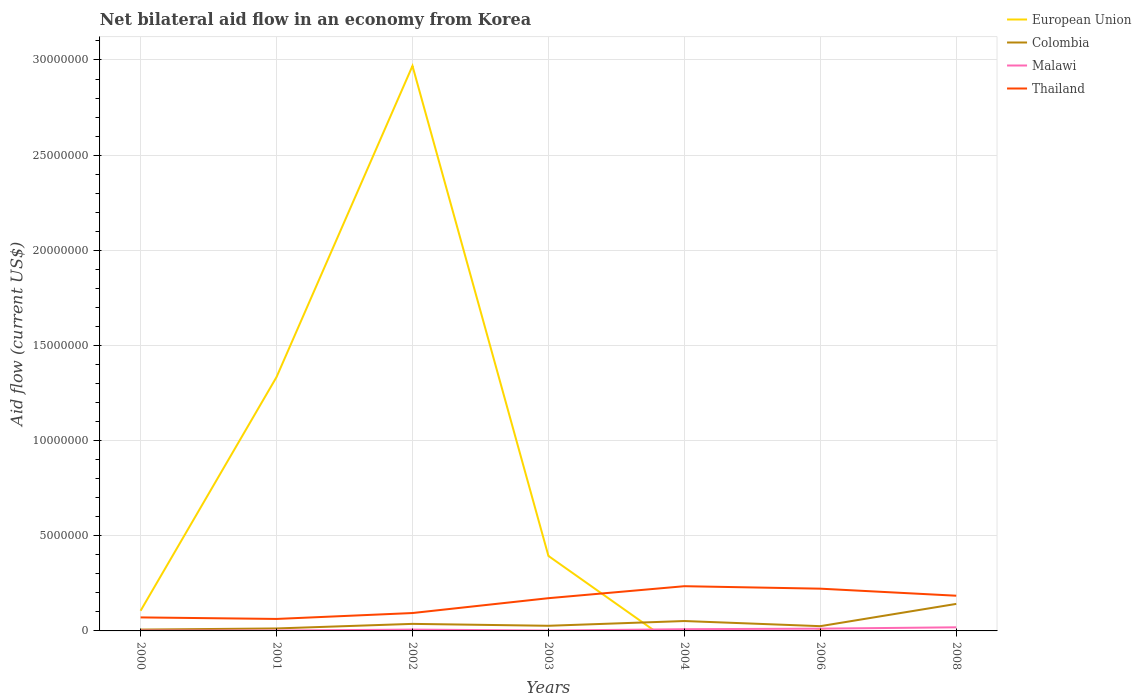Across all years, what is the maximum net bilateral aid flow in Malawi?
Provide a short and direct response. 2.00e+04. What is the total net bilateral aid flow in Thailand in the graph?
Make the answer very short. -7.80e+05. What is the difference between the highest and the lowest net bilateral aid flow in Malawi?
Provide a short and direct response. 3. How many years are there in the graph?
Offer a very short reply. 7. What is the difference between two consecutive major ticks on the Y-axis?
Your answer should be compact. 5.00e+06. Are the values on the major ticks of Y-axis written in scientific E-notation?
Offer a very short reply. No. Does the graph contain grids?
Make the answer very short. Yes. How are the legend labels stacked?
Provide a succinct answer. Vertical. What is the title of the graph?
Provide a succinct answer. Net bilateral aid flow in an economy from Korea. Does "Netherlands" appear as one of the legend labels in the graph?
Provide a succinct answer. No. What is the label or title of the X-axis?
Keep it short and to the point. Years. What is the label or title of the Y-axis?
Your response must be concise. Aid flow (current US$). What is the Aid flow (current US$) of European Union in 2000?
Give a very brief answer. 1.06e+06. What is the Aid flow (current US$) of Thailand in 2000?
Your answer should be very brief. 7.10e+05. What is the Aid flow (current US$) in European Union in 2001?
Your answer should be very brief. 1.33e+07. What is the Aid flow (current US$) of Malawi in 2001?
Your answer should be compact. 2.00e+04. What is the Aid flow (current US$) in Thailand in 2001?
Your response must be concise. 6.30e+05. What is the Aid flow (current US$) in European Union in 2002?
Keep it short and to the point. 2.97e+07. What is the Aid flow (current US$) of Thailand in 2002?
Offer a terse response. 9.40e+05. What is the Aid flow (current US$) of European Union in 2003?
Keep it short and to the point. 3.94e+06. What is the Aid flow (current US$) in Malawi in 2003?
Make the answer very short. 2.00e+04. What is the Aid flow (current US$) of Thailand in 2003?
Make the answer very short. 1.72e+06. What is the Aid flow (current US$) of Colombia in 2004?
Provide a short and direct response. 5.20e+05. What is the Aid flow (current US$) in Thailand in 2004?
Ensure brevity in your answer.  2.35e+06. What is the Aid flow (current US$) of European Union in 2006?
Ensure brevity in your answer.  5.00e+04. What is the Aid flow (current US$) in Colombia in 2006?
Keep it short and to the point. 2.50e+05. What is the Aid flow (current US$) of Thailand in 2006?
Provide a succinct answer. 2.22e+06. What is the Aid flow (current US$) in European Union in 2008?
Provide a succinct answer. 0. What is the Aid flow (current US$) in Colombia in 2008?
Keep it short and to the point. 1.42e+06. What is the Aid flow (current US$) of Thailand in 2008?
Provide a succinct answer. 1.85e+06. Across all years, what is the maximum Aid flow (current US$) of European Union?
Provide a short and direct response. 2.97e+07. Across all years, what is the maximum Aid flow (current US$) in Colombia?
Offer a terse response. 1.42e+06. Across all years, what is the maximum Aid flow (current US$) in Thailand?
Offer a very short reply. 2.35e+06. Across all years, what is the minimum Aid flow (current US$) of European Union?
Keep it short and to the point. 0. Across all years, what is the minimum Aid flow (current US$) of Colombia?
Provide a succinct answer. 7.00e+04. Across all years, what is the minimum Aid flow (current US$) of Malawi?
Your answer should be compact. 2.00e+04. Across all years, what is the minimum Aid flow (current US$) of Thailand?
Your answer should be compact. 6.30e+05. What is the total Aid flow (current US$) of European Union in the graph?
Give a very brief answer. 4.81e+07. What is the total Aid flow (current US$) of Colombia in the graph?
Your answer should be compact. 3.03e+06. What is the total Aid flow (current US$) in Malawi in the graph?
Offer a terse response. 5.30e+05. What is the total Aid flow (current US$) of Thailand in the graph?
Give a very brief answer. 1.04e+07. What is the difference between the Aid flow (current US$) of European Union in 2000 and that in 2001?
Provide a succinct answer. -1.23e+07. What is the difference between the Aid flow (current US$) in Colombia in 2000 and that in 2001?
Your response must be concise. -6.00e+04. What is the difference between the Aid flow (current US$) in Thailand in 2000 and that in 2001?
Your answer should be very brief. 8.00e+04. What is the difference between the Aid flow (current US$) of European Union in 2000 and that in 2002?
Give a very brief answer. -2.86e+07. What is the difference between the Aid flow (current US$) in Colombia in 2000 and that in 2002?
Your response must be concise. -3.00e+05. What is the difference between the Aid flow (current US$) of Thailand in 2000 and that in 2002?
Your response must be concise. -2.30e+05. What is the difference between the Aid flow (current US$) of European Union in 2000 and that in 2003?
Offer a very short reply. -2.88e+06. What is the difference between the Aid flow (current US$) of Malawi in 2000 and that in 2003?
Keep it short and to the point. 0. What is the difference between the Aid flow (current US$) of Thailand in 2000 and that in 2003?
Make the answer very short. -1.01e+06. What is the difference between the Aid flow (current US$) in Colombia in 2000 and that in 2004?
Your response must be concise. -4.50e+05. What is the difference between the Aid flow (current US$) of Thailand in 2000 and that in 2004?
Provide a succinct answer. -1.64e+06. What is the difference between the Aid flow (current US$) in European Union in 2000 and that in 2006?
Make the answer very short. 1.01e+06. What is the difference between the Aid flow (current US$) of Thailand in 2000 and that in 2006?
Make the answer very short. -1.51e+06. What is the difference between the Aid flow (current US$) in Colombia in 2000 and that in 2008?
Make the answer very short. -1.35e+06. What is the difference between the Aid flow (current US$) in Malawi in 2000 and that in 2008?
Ensure brevity in your answer.  -1.70e+05. What is the difference between the Aid flow (current US$) in Thailand in 2000 and that in 2008?
Your response must be concise. -1.14e+06. What is the difference between the Aid flow (current US$) of European Union in 2001 and that in 2002?
Your answer should be compact. -1.64e+07. What is the difference between the Aid flow (current US$) in Malawi in 2001 and that in 2002?
Provide a succinct answer. -5.00e+04. What is the difference between the Aid flow (current US$) of Thailand in 2001 and that in 2002?
Your answer should be compact. -3.10e+05. What is the difference between the Aid flow (current US$) in European Union in 2001 and that in 2003?
Make the answer very short. 9.40e+06. What is the difference between the Aid flow (current US$) in Thailand in 2001 and that in 2003?
Offer a very short reply. -1.09e+06. What is the difference between the Aid flow (current US$) in Colombia in 2001 and that in 2004?
Your answer should be compact. -3.90e+05. What is the difference between the Aid flow (current US$) of Thailand in 2001 and that in 2004?
Provide a short and direct response. -1.72e+06. What is the difference between the Aid flow (current US$) in European Union in 2001 and that in 2006?
Offer a terse response. 1.33e+07. What is the difference between the Aid flow (current US$) in Malawi in 2001 and that in 2006?
Give a very brief answer. -1.00e+05. What is the difference between the Aid flow (current US$) in Thailand in 2001 and that in 2006?
Your answer should be compact. -1.59e+06. What is the difference between the Aid flow (current US$) of Colombia in 2001 and that in 2008?
Ensure brevity in your answer.  -1.29e+06. What is the difference between the Aid flow (current US$) of Thailand in 2001 and that in 2008?
Your response must be concise. -1.22e+06. What is the difference between the Aid flow (current US$) of European Union in 2002 and that in 2003?
Offer a terse response. 2.58e+07. What is the difference between the Aid flow (current US$) in Colombia in 2002 and that in 2003?
Provide a succinct answer. 1.00e+05. What is the difference between the Aid flow (current US$) in Malawi in 2002 and that in 2003?
Offer a terse response. 5.00e+04. What is the difference between the Aid flow (current US$) of Thailand in 2002 and that in 2003?
Make the answer very short. -7.80e+05. What is the difference between the Aid flow (current US$) of Thailand in 2002 and that in 2004?
Ensure brevity in your answer.  -1.41e+06. What is the difference between the Aid flow (current US$) in European Union in 2002 and that in 2006?
Offer a terse response. 2.96e+07. What is the difference between the Aid flow (current US$) of Colombia in 2002 and that in 2006?
Make the answer very short. 1.20e+05. What is the difference between the Aid flow (current US$) of Malawi in 2002 and that in 2006?
Your response must be concise. -5.00e+04. What is the difference between the Aid flow (current US$) in Thailand in 2002 and that in 2006?
Ensure brevity in your answer.  -1.28e+06. What is the difference between the Aid flow (current US$) in Colombia in 2002 and that in 2008?
Your answer should be very brief. -1.05e+06. What is the difference between the Aid flow (current US$) of Malawi in 2002 and that in 2008?
Ensure brevity in your answer.  -1.20e+05. What is the difference between the Aid flow (current US$) of Thailand in 2002 and that in 2008?
Offer a very short reply. -9.10e+05. What is the difference between the Aid flow (current US$) of Malawi in 2003 and that in 2004?
Provide a short and direct response. -7.00e+04. What is the difference between the Aid flow (current US$) of Thailand in 2003 and that in 2004?
Your response must be concise. -6.30e+05. What is the difference between the Aid flow (current US$) in European Union in 2003 and that in 2006?
Your response must be concise. 3.89e+06. What is the difference between the Aid flow (current US$) in Malawi in 2003 and that in 2006?
Your answer should be compact. -1.00e+05. What is the difference between the Aid flow (current US$) in Thailand in 2003 and that in 2006?
Provide a short and direct response. -5.00e+05. What is the difference between the Aid flow (current US$) in Colombia in 2003 and that in 2008?
Your answer should be compact. -1.15e+06. What is the difference between the Aid flow (current US$) in Malawi in 2003 and that in 2008?
Make the answer very short. -1.70e+05. What is the difference between the Aid flow (current US$) in Thailand in 2003 and that in 2008?
Give a very brief answer. -1.30e+05. What is the difference between the Aid flow (current US$) of Colombia in 2004 and that in 2006?
Your answer should be very brief. 2.70e+05. What is the difference between the Aid flow (current US$) of Malawi in 2004 and that in 2006?
Provide a succinct answer. -3.00e+04. What is the difference between the Aid flow (current US$) of Colombia in 2004 and that in 2008?
Your answer should be very brief. -9.00e+05. What is the difference between the Aid flow (current US$) in Colombia in 2006 and that in 2008?
Your answer should be compact. -1.17e+06. What is the difference between the Aid flow (current US$) in European Union in 2000 and the Aid flow (current US$) in Colombia in 2001?
Make the answer very short. 9.30e+05. What is the difference between the Aid flow (current US$) of European Union in 2000 and the Aid flow (current US$) of Malawi in 2001?
Your answer should be compact. 1.04e+06. What is the difference between the Aid flow (current US$) in Colombia in 2000 and the Aid flow (current US$) in Malawi in 2001?
Provide a short and direct response. 5.00e+04. What is the difference between the Aid flow (current US$) of Colombia in 2000 and the Aid flow (current US$) of Thailand in 2001?
Offer a terse response. -5.60e+05. What is the difference between the Aid flow (current US$) in Malawi in 2000 and the Aid flow (current US$) in Thailand in 2001?
Provide a short and direct response. -6.10e+05. What is the difference between the Aid flow (current US$) of European Union in 2000 and the Aid flow (current US$) of Colombia in 2002?
Your response must be concise. 6.90e+05. What is the difference between the Aid flow (current US$) in European Union in 2000 and the Aid flow (current US$) in Malawi in 2002?
Your response must be concise. 9.90e+05. What is the difference between the Aid flow (current US$) in Colombia in 2000 and the Aid flow (current US$) in Malawi in 2002?
Give a very brief answer. 0. What is the difference between the Aid flow (current US$) in Colombia in 2000 and the Aid flow (current US$) in Thailand in 2002?
Provide a short and direct response. -8.70e+05. What is the difference between the Aid flow (current US$) in Malawi in 2000 and the Aid flow (current US$) in Thailand in 2002?
Give a very brief answer. -9.20e+05. What is the difference between the Aid flow (current US$) of European Union in 2000 and the Aid flow (current US$) of Colombia in 2003?
Give a very brief answer. 7.90e+05. What is the difference between the Aid flow (current US$) in European Union in 2000 and the Aid flow (current US$) in Malawi in 2003?
Offer a very short reply. 1.04e+06. What is the difference between the Aid flow (current US$) of European Union in 2000 and the Aid flow (current US$) of Thailand in 2003?
Provide a succinct answer. -6.60e+05. What is the difference between the Aid flow (current US$) of Colombia in 2000 and the Aid flow (current US$) of Thailand in 2003?
Provide a short and direct response. -1.65e+06. What is the difference between the Aid flow (current US$) of Malawi in 2000 and the Aid flow (current US$) of Thailand in 2003?
Provide a succinct answer. -1.70e+06. What is the difference between the Aid flow (current US$) of European Union in 2000 and the Aid flow (current US$) of Colombia in 2004?
Provide a succinct answer. 5.40e+05. What is the difference between the Aid flow (current US$) of European Union in 2000 and the Aid flow (current US$) of Malawi in 2004?
Offer a terse response. 9.70e+05. What is the difference between the Aid flow (current US$) in European Union in 2000 and the Aid flow (current US$) in Thailand in 2004?
Offer a terse response. -1.29e+06. What is the difference between the Aid flow (current US$) of Colombia in 2000 and the Aid flow (current US$) of Thailand in 2004?
Your response must be concise. -2.28e+06. What is the difference between the Aid flow (current US$) in Malawi in 2000 and the Aid flow (current US$) in Thailand in 2004?
Keep it short and to the point. -2.33e+06. What is the difference between the Aid flow (current US$) in European Union in 2000 and the Aid flow (current US$) in Colombia in 2006?
Keep it short and to the point. 8.10e+05. What is the difference between the Aid flow (current US$) of European Union in 2000 and the Aid flow (current US$) of Malawi in 2006?
Your answer should be compact. 9.40e+05. What is the difference between the Aid flow (current US$) in European Union in 2000 and the Aid flow (current US$) in Thailand in 2006?
Offer a very short reply. -1.16e+06. What is the difference between the Aid flow (current US$) in Colombia in 2000 and the Aid flow (current US$) in Thailand in 2006?
Provide a short and direct response. -2.15e+06. What is the difference between the Aid flow (current US$) of Malawi in 2000 and the Aid flow (current US$) of Thailand in 2006?
Your answer should be compact. -2.20e+06. What is the difference between the Aid flow (current US$) of European Union in 2000 and the Aid flow (current US$) of Colombia in 2008?
Provide a succinct answer. -3.60e+05. What is the difference between the Aid flow (current US$) of European Union in 2000 and the Aid flow (current US$) of Malawi in 2008?
Your answer should be compact. 8.70e+05. What is the difference between the Aid flow (current US$) in European Union in 2000 and the Aid flow (current US$) in Thailand in 2008?
Provide a succinct answer. -7.90e+05. What is the difference between the Aid flow (current US$) of Colombia in 2000 and the Aid flow (current US$) of Malawi in 2008?
Give a very brief answer. -1.20e+05. What is the difference between the Aid flow (current US$) in Colombia in 2000 and the Aid flow (current US$) in Thailand in 2008?
Your answer should be compact. -1.78e+06. What is the difference between the Aid flow (current US$) in Malawi in 2000 and the Aid flow (current US$) in Thailand in 2008?
Provide a succinct answer. -1.83e+06. What is the difference between the Aid flow (current US$) of European Union in 2001 and the Aid flow (current US$) of Colombia in 2002?
Give a very brief answer. 1.30e+07. What is the difference between the Aid flow (current US$) of European Union in 2001 and the Aid flow (current US$) of Malawi in 2002?
Keep it short and to the point. 1.33e+07. What is the difference between the Aid flow (current US$) in European Union in 2001 and the Aid flow (current US$) in Thailand in 2002?
Ensure brevity in your answer.  1.24e+07. What is the difference between the Aid flow (current US$) in Colombia in 2001 and the Aid flow (current US$) in Malawi in 2002?
Make the answer very short. 6.00e+04. What is the difference between the Aid flow (current US$) of Colombia in 2001 and the Aid flow (current US$) of Thailand in 2002?
Make the answer very short. -8.10e+05. What is the difference between the Aid flow (current US$) of Malawi in 2001 and the Aid flow (current US$) of Thailand in 2002?
Your answer should be compact. -9.20e+05. What is the difference between the Aid flow (current US$) of European Union in 2001 and the Aid flow (current US$) of Colombia in 2003?
Keep it short and to the point. 1.31e+07. What is the difference between the Aid flow (current US$) in European Union in 2001 and the Aid flow (current US$) in Malawi in 2003?
Give a very brief answer. 1.33e+07. What is the difference between the Aid flow (current US$) in European Union in 2001 and the Aid flow (current US$) in Thailand in 2003?
Provide a succinct answer. 1.16e+07. What is the difference between the Aid flow (current US$) in Colombia in 2001 and the Aid flow (current US$) in Thailand in 2003?
Keep it short and to the point. -1.59e+06. What is the difference between the Aid flow (current US$) in Malawi in 2001 and the Aid flow (current US$) in Thailand in 2003?
Provide a short and direct response. -1.70e+06. What is the difference between the Aid flow (current US$) in European Union in 2001 and the Aid flow (current US$) in Colombia in 2004?
Your answer should be compact. 1.28e+07. What is the difference between the Aid flow (current US$) in European Union in 2001 and the Aid flow (current US$) in Malawi in 2004?
Your answer should be compact. 1.32e+07. What is the difference between the Aid flow (current US$) of European Union in 2001 and the Aid flow (current US$) of Thailand in 2004?
Your answer should be compact. 1.10e+07. What is the difference between the Aid flow (current US$) in Colombia in 2001 and the Aid flow (current US$) in Thailand in 2004?
Offer a terse response. -2.22e+06. What is the difference between the Aid flow (current US$) of Malawi in 2001 and the Aid flow (current US$) of Thailand in 2004?
Give a very brief answer. -2.33e+06. What is the difference between the Aid flow (current US$) in European Union in 2001 and the Aid flow (current US$) in Colombia in 2006?
Your response must be concise. 1.31e+07. What is the difference between the Aid flow (current US$) of European Union in 2001 and the Aid flow (current US$) of Malawi in 2006?
Give a very brief answer. 1.32e+07. What is the difference between the Aid flow (current US$) in European Union in 2001 and the Aid flow (current US$) in Thailand in 2006?
Provide a short and direct response. 1.11e+07. What is the difference between the Aid flow (current US$) in Colombia in 2001 and the Aid flow (current US$) in Malawi in 2006?
Ensure brevity in your answer.  10000. What is the difference between the Aid flow (current US$) of Colombia in 2001 and the Aid flow (current US$) of Thailand in 2006?
Provide a short and direct response. -2.09e+06. What is the difference between the Aid flow (current US$) of Malawi in 2001 and the Aid flow (current US$) of Thailand in 2006?
Your response must be concise. -2.20e+06. What is the difference between the Aid flow (current US$) in European Union in 2001 and the Aid flow (current US$) in Colombia in 2008?
Offer a terse response. 1.19e+07. What is the difference between the Aid flow (current US$) of European Union in 2001 and the Aid flow (current US$) of Malawi in 2008?
Keep it short and to the point. 1.32e+07. What is the difference between the Aid flow (current US$) of European Union in 2001 and the Aid flow (current US$) of Thailand in 2008?
Provide a short and direct response. 1.15e+07. What is the difference between the Aid flow (current US$) in Colombia in 2001 and the Aid flow (current US$) in Malawi in 2008?
Your answer should be very brief. -6.00e+04. What is the difference between the Aid flow (current US$) in Colombia in 2001 and the Aid flow (current US$) in Thailand in 2008?
Keep it short and to the point. -1.72e+06. What is the difference between the Aid flow (current US$) in Malawi in 2001 and the Aid flow (current US$) in Thailand in 2008?
Offer a very short reply. -1.83e+06. What is the difference between the Aid flow (current US$) in European Union in 2002 and the Aid flow (current US$) in Colombia in 2003?
Offer a terse response. 2.94e+07. What is the difference between the Aid flow (current US$) of European Union in 2002 and the Aid flow (current US$) of Malawi in 2003?
Give a very brief answer. 2.97e+07. What is the difference between the Aid flow (current US$) of European Union in 2002 and the Aid flow (current US$) of Thailand in 2003?
Ensure brevity in your answer.  2.80e+07. What is the difference between the Aid flow (current US$) in Colombia in 2002 and the Aid flow (current US$) in Malawi in 2003?
Your response must be concise. 3.50e+05. What is the difference between the Aid flow (current US$) in Colombia in 2002 and the Aid flow (current US$) in Thailand in 2003?
Your answer should be very brief. -1.35e+06. What is the difference between the Aid flow (current US$) of Malawi in 2002 and the Aid flow (current US$) of Thailand in 2003?
Your answer should be very brief. -1.65e+06. What is the difference between the Aid flow (current US$) of European Union in 2002 and the Aid flow (current US$) of Colombia in 2004?
Make the answer very short. 2.92e+07. What is the difference between the Aid flow (current US$) in European Union in 2002 and the Aid flow (current US$) in Malawi in 2004?
Give a very brief answer. 2.96e+07. What is the difference between the Aid flow (current US$) of European Union in 2002 and the Aid flow (current US$) of Thailand in 2004?
Your answer should be very brief. 2.73e+07. What is the difference between the Aid flow (current US$) in Colombia in 2002 and the Aid flow (current US$) in Malawi in 2004?
Offer a very short reply. 2.80e+05. What is the difference between the Aid flow (current US$) in Colombia in 2002 and the Aid flow (current US$) in Thailand in 2004?
Provide a succinct answer. -1.98e+06. What is the difference between the Aid flow (current US$) in Malawi in 2002 and the Aid flow (current US$) in Thailand in 2004?
Your response must be concise. -2.28e+06. What is the difference between the Aid flow (current US$) in European Union in 2002 and the Aid flow (current US$) in Colombia in 2006?
Provide a short and direct response. 2.94e+07. What is the difference between the Aid flow (current US$) of European Union in 2002 and the Aid flow (current US$) of Malawi in 2006?
Your answer should be compact. 2.96e+07. What is the difference between the Aid flow (current US$) of European Union in 2002 and the Aid flow (current US$) of Thailand in 2006?
Offer a very short reply. 2.75e+07. What is the difference between the Aid flow (current US$) of Colombia in 2002 and the Aid flow (current US$) of Malawi in 2006?
Offer a terse response. 2.50e+05. What is the difference between the Aid flow (current US$) of Colombia in 2002 and the Aid flow (current US$) of Thailand in 2006?
Provide a succinct answer. -1.85e+06. What is the difference between the Aid flow (current US$) in Malawi in 2002 and the Aid flow (current US$) in Thailand in 2006?
Your answer should be very brief. -2.15e+06. What is the difference between the Aid flow (current US$) in European Union in 2002 and the Aid flow (current US$) in Colombia in 2008?
Make the answer very short. 2.83e+07. What is the difference between the Aid flow (current US$) in European Union in 2002 and the Aid flow (current US$) in Malawi in 2008?
Your answer should be very brief. 2.95e+07. What is the difference between the Aid flow (current US$) in European Union in 2002 and the Aid flow (current US$) in Thailand in 2008?
Give a very brief answer. 2.78e+07. What is the difference between the Aid flow (current US$) of Colombia in 2002 and the Aid flow (current US$) of Malawi in 2008?
Give a very brief answer. 1.80e+05. What is the difference between the Aid flow (current US$) in Colombia in 2002 and the Aid flow (current US$) in Thailand in 2008?
Provide a succinct answer. -1.48e+06. What is the difference between the Aid flow (current US$) in Malawi in 2002 and the Aid flow (current US$) in Thailand in 2008?
Offer a very short reply. -1.78e+06. What is the difference between the Aid flow (current US$) of European Union in 2003 and the Aid flow (current US$) of Colombia in 2004?
Offer a very short reply. 3.42e+06. What is the difference between the Aid flow (current US$) in European Union in 2003 and the Aid flow (current US$) in Malawi in 2004?
Your answer should be very brief. 3.85e+06. What is the difference between the Aid flow (current US$) of European Union in 2003 and the Aid flow (current US$) of Thailand in 2004?
Make the answer very short. 1.59e+06. What is the difference between the Aid flow (current US$) in Colombia in 2003 and the Aid flow (current US$) in Thailand in 2004?
Give a very brief answer. -2.08e+06. What is the difference between the Aid flow (current US$) in Malawi in 2003 and the Aid flow (current US$) in Thailand in 2004?
Ensure brevity in your answer.  -2.33e+06. What is the difference between the Aid flow (current US$) in European Union in 2003 and the Aid flow (current US$) in Colombia in 2006?
Make the answer very short. 3.69e+06. What is the difference between the Aid flow (current US$) of European Union in 2003 and the Aid flow (current US$) of Malawi in 2006?
Offer a very short reply. 3.82e+06. What is the difference between the Aid flow (current US$) of European Union in 2003 and the Aid flow (current US$) of Thailand in 2006?
Your answer should be compact. 1.72e+06. What is the difference between the Aid flow (current US$) in Colombia in 2003 and the Aid flow (current US$) in Malawi in 2006?
Provide a short and direct response. 1.50e+05. What is the difference between the Aid flow (current US$) of Colombia in 2003 and the Aid flow (current US$) of Thailand in 2006?
Make the answer very short. -1.95e+06. What is the difference between the Aid flow (current US$) in Malawi in 2003 and the Aid flow (current US$) in Thailand in 2006?
Your response must be concise. -2.20e+06. What is the difference between the Aid flow (current US$) of European Union in 2003 and the Aid flow (current US$) of Colombia in 2008?
Your response must be concise. 2.52e+06. What is the difference between the Aid flow (current US$) of European Union in 2003 and the Aid flow (current US$) of Malawi in 2008?
Provide a short and direct response. 3.75e+06. What is the difference between the Aid flow (current US$) in European Union in 2003 and the Aid flow (current US$) in Thailand in 2008?
Make the answer very short. 2.09e+06. What is the difference between the Aid flow (current US$) in Colombia in 2003 and the Aid flow (current US$) in Thailand in 2008?
Your answer should be compact. -1.58e+06. What is the difference between the Aid flow (current US$) of Malawi in 2003 and the Aid flow (current US$) of Thailand in 2008?
Your answer should be compact. -1.83e+06. What is the difference between the Aid flow (current US$) in Colombia in 2004 and the Aid flow (current US$) in Thailand in 2006?
Ensure brevity in your answer.  -1.70e+06. What is the difference between the Aid flow (current US$) in Malawi in 2004 and the Aid flow (current US$) in Thailand in 2006?
Give a very brief answer. -2.13e+06. What is the difference between the Aid flow (current US$) in Colombia in 2004 and the Aid flow (current US$) in Thailand in 2008?
Provide a succinct answer. -1.33e+06. What is the difference between the Aid flow (current US$) in Malawi in 2004 and the Aid flow (current US$) in Thailand in 2008?
Your answer should be very brief. -1.76e+06. What is the difference between the Aid flow (current US$) in European Union in 2006 and the Aid flow (current US$) in Colombia in 2008?
Your answer should be compact. -1.37e+06. What is the difference between the Aid flow (current US$) of European Union in 2006 and the Aid flow (current US$) of Thailand in 2008?
Keep it short and to the point. -1.80e+06. What is the difference between the Aid flow (current US$) of Colombia in 2006 and the Aid flow (current US$) of Malawi in 2008?
Offer a terse response. 6.00e+04. What is the difference between the Aid flow (current US$) in Colombia in 2006 and the Aid flow (current US$) in Thailand in 2008?
Ensure brevity in your answer.  -1.60e+06. What is the difference between the Aid flow (current US$) of Malawi in 2006 and the Aid flow (current US$) of Thailand in 2008?
Your answer should be compact. -1.73e+06. What is the average Aid flow (current US$) in European Union per year?
Your answer should be compact. 6.87e+06. What is the average Aid flow (current US$) of Colombia per year?
Your answer should be compact. 4.33e+05. What is the average Aid flow (current US$) of Malawi per year?
Your answer should be compact. 7.57e+04. What is the average Aid flow (current US$) in Thailand per year?
Offer a very short reply. 1.49e+06. In the year 2000, what is the difference between the Aid flow (current US$) in European Union and Aid flow (current US$) in Colombia?
Provide a succinct answer. 9.90e+05. In the year 2000, what is the difference between the Aid flow (current US$) in European Union and Aid flow (current US$) in Malawi?
Your response must be concise. 1.04e+06. In the year 2000, what is the difference between the Aid flow (current US$) in European Union and Aid flow (current US$) in Thailand?
Ensure brevity in your answer.  3.50e+05. In the year 2000, what is the difference between the Aid flow (current US$) of Colombia and Aid flow (current US$) of Malawi?
Your answer should be very brief. 5.00e+04. In the year 2000, what is the difference between the Aid flow (current US$) of Colombia and Aid flow (current US$) of Thailand?
Your answer should be very brief. -6.40e+05. In the year 2000, what is the difference between the Aid flow (current US$) in Malawi and Aid flow (current US$) in Thailand?
Ensure brevity in your answer.  -6.90e+05. In the year 2001, what is the difference between the Aid flow (current US$) in European Union and Aid flow (current US$) in Colombia?
Your response must be concise. 1.32e+07. In the year 2001, what is the difference between the Aid flow (current US$) in European Union and Aid flow (current US$) in Malawi?
Your answer should be very brief. 1.33e+07. In the year 2001, what is the difference between the Aid flow (current US$) in European Union and Aid flow (current US$) in Thailand?
Offer a terse response. 1.27e+07. In the year 2001, what is the difference between the Aid flow (current US$) in Colombia and Aid flow (current US$) in Malawi?
Your answer should be very brief. 1.10e+05. In the year 2001, what is the difference between the Aid flow (current US$) of Colombia and Aid flow (current US$) of Thailand?
Your response must be concise. -5.00e+05. In the year 2001, what is the difference between the Aid flow (current US$) in Malawi and Aid flow (current US$) in Thailand?
Make the answer very short. -6.10e+05. In the year 2002, what is the difference between the Aid flow (current US$) of European Union and Aid flow (current US$) of Colombia?
Keep it short and to the point. 2.93e+07. In the year 2002, what is the difference between the Aid flow (current US$) of European Union and Aid flow (current US$) of Malawi?
Ensure brevity in your answer.  2.96e+07. In the year 2002, what is the difference between the Aid flow (current US$) in European Union and Aid flow (current US$) in Thailand?
Your answer should be compact. 2.88e+07. In the year 2002, what is the difference between the Aid flow (current US$) in Colombia and Aid flow (current US$) in Malawi?
Your answer should be compact. 3.00e+05. In the year 2002, what is the difference between the Aid flow (current US$) in Colombia and Aid flow (current US$) in Thailand?
Offer a terse response. -5.70e+05. In the year 2002, what is the difference between the Aid flow (current US$) of Malawi and Aid flow (current US$) of Thailand?
Provide a short and direct response. -8.70e+05. In the year 2003, what is the difference between the Aid flow (current US$) in European Union and Aid flow (current US$) in Colombia?
Your answer should be very brief. 3.67e+06. In the year 2003, what is the difference between the Aid flow (current US$) in European Union and Aid flow (current US$) in Malawi?
Provide a short and direct response. 3.92e+06. In the year 2003, what is the difference between the Aid flow (current US$) in European Union and Aid flow (current US$) in Thailand?
Keep it short and to the point. 2.22e+06. In the year 2003, what is the difference between the Aid flow (current US$) of Colombia and Aid flow (current US$) of Malawi?
Offer a terse response. 2.50e+05. In the year 2003, what is the difference between the Aid flow (current US$) of Colombia and Aid flow (current US$) of Thailand?
Your answer should be very brief. -1.45e+06. In the year 2003, what is the difference between the Aid flow (current US$) of Malawi and Aid flow (current US$) of Thailand?
Offer a terse response. -1.70e+06. In the year 2004, what is the difference between the Aid flow (current US$) of Colombia and Aid flow (current US$) of Thailand?
Your answer should be very brief. -1.83e+06. In the year 2004, what is the difference between the Aid flow (current US$) of Malawi and Aid flow (current US$) of Thailand?
Provide a succinct answer. -2.26e+06. In the year 2006, what is the difference between the Aid flow (current US$) in European Union and Aid flow (current US$) in Thailand?
Your answer should be very brief. -2.17e+06. In the year 2006, what is the difference between the Aid flow (current US$) in Colombia and Aid flow (current US$) in Malawi?
Give a very brief answer. 1.30e+05. In the year 2006, what is the difference between the Aid flow (current US$) of Colombia and Aid flow (current US$) of Thailand?
Your answer should be compact. -1.97e+06. In the year 2006, what is the difference between the Aid flow (current US$) in Malawi and Aid flow (current US$) in Thailand?
Give a very brief answer. -2.10e+06. In the year 2008, what is the difference between the Aid flow (current US$) in Colombia and Aid flow (current US$) in Malawi?
Ensure brevity in your answer.  1.23e+06. In the year 2008, what is the difference between the Aid flow (current US$) in Colombia and Aid flow (current US$) in Thailand?
Your answer should be compact. -4.30e+05. In the year 2008, what is the difference between the Aid flow (current US$) in Malawi and Aid flow (current US$) in Thailand?
Offer a very short reply. -1.66e+06. What is the ratio of the Aid flow (current US$) of European Union in 2000 to that in 2001?
Offer a terse response. 0.08. What is the ratio of the Aid flow (current US$) in Colombia in 2000 to that in 2001?
Your answer should be compact. 0.54. What is the ratio of the Aid flow (current US$) in Malawi in 2000 to that in 2001?
Your response must be concise. 1. What is the ratio of the Aid flow (current US$) in Thailand in 2000 to that in 2001?
Ensure brevity in your answer.  1.13. What is the ratio of the Aid flow (current US$) of European Union in 2000 to that in 2002?
Offer a terse response. 0.04. What is the ratio of the Aid flow (current US$) in Colombia in 2000 to that in 2002?
Provide a succinct answer. 0.19. What is the ratio of the Aid flow (current US$) of Malawi in 2000 to that in 2002?
Keep it short and to the point. 0.29. What is the ratio of the Aid flow (current US$) in Thailand in 2000 to that in 2002?
Make the answer very short. 0.76. What is the ratio of the Aid flow (current US$) in European Union in 2000 to that in 2003?
Your answer should be very brief. 0.27. What is the ratio of the Aid flow (current US$) in Colombia in 2000 to that in 2003?
Ensure brevity in your answer.  0.26. What is the ratio of the Aid flow (current US$) in Thailand in 2000 to that in 2003?
Provide a succinct answer. 0.41. What is the ratio of the Aid flow (current US$) in Colombia in 2000 to that in 2004?
Make the answer very short. 0.13. What is the ratio of the Aid flow (current US$) in Malawi in 2000 to that in 2004?
Provide a succinct answer. 0.22. What is the ratio of the Aid flow (current US$) of Thailand in 2000 to that in 2004?
Provide a short and direct response. 0.3. What is the ratio of the Aid flow (current US$) of European Union in 2000 to that in 2006?
Keep it short and to the point. 21.2. What is the ratio of the Aid flow (current US$) in Colombia in 2000 to that in 2006?
Give a very brief answer. 0.28. What is the ratio of the Aid flow (current US$) in Thailand in 2000 to that in 2006?
Your answer should be very brief. 0.32. What is the ratio of the Aid flow (current US$) in Colombia in 2000 to that in 2008?
Offer a very short reply. 0.05. What is the ratio of the Aid flow (current US$) in Malawi in 2000 to that in 2008?
Your response must be concise. 0.11. What is the ratio of the Aid flow (current US$) in Thailand in 2000 to that in 2008?
Give a very brief answer. 0.38. What is the ratio of the Aid flow (current US$) in European Union in 2001 to that in 2002?
Offer a terse response. 0.45. What is the ratio of the Aid flow (current US$) in Colombia in 2001 to that in 2002?
Your answer should be compact. 0.35. What is the ratio of the Aid flow (current US$) in Malawi in 2001 to that in 2002?
Make the answer very short. 0.29. What is the ratio of the Aid flow (current US$) of Thailand in 2001 to that in 2002?
Offer a very short reply. 0.67. What is the ratio of the Aid flow (current US$) of European Union in 2001 to that in 2003?
Ensure brevity in your answer.  3.39. What is the ratio of the Aid flow (current US$) of Colombia in 2001 to that in 2003?
Provide a short and direct response. 0.48. What is the ratio of the Aid flow (current US$) in Malawi in 2001 to that in 2003?
Ensure brevity in your answer.  1. What is the ratio of the Aid flow (current US$) of Thailand in 2001 to that in 2003?
Offer a very short reply. 0.37. What is the ratio of the Aid flow (current US$) of Colombia in 2001 to that in 2004?
Give a very brief answer. 0.25. What is the ratio of the Aid flow (current US$) in Malawi in 2001 to that in 2004?
Your response must be concise. 0.22. What is the ratio of the Aid flow (current US$) in Thailand in 2001 to that in 2004?
Your response must be concise. 0.27. What is the ratio of the Aid flow (current US$) in European Union in 2001 to that in 2006?
Your answer should be compact. 266.8. What is the ratio of the Aid flow (current US$) in Colombia in 2001 to that in 2006?
Your answer should be compact. 0.52. What is the ratio of the Aid flow (current US$) of Malawi in 2001 to that in 2006?
Give a very brief answer. 0.17. What is the ratio of the Aid flow (current US$) of Thailand in 2001 to that in 2006?
Your response must be concise. 0.28. What is the ratio of the Aid flow (current US$) in Colombia in 2001 to that in 2008?
Offer a very short reply. 0.09. What is the ratio of the Aid flow (current US$) of Malawi in 2001 to that in 2008?
Keep it short and to the point. 0.11. What is the ratio of the Aid flow (current US$) of Thailand in 2001 to that in 2008?
Your answer should be compact. 0.34. What is the ratio of the Aid flow (current US$) in European Union in 2002 to that in 2003?
Offer a terse response. 7.54. What is the ratio of the Aid flow (current US$) in Colombia in 2002 to that in 2003?
Offer a terse response. 1.37. What is the ratio of the Aid flow (current US$) in Malawi in 2002 to that in 2003?
Your answer should be compact. 3.5. What is the ratio of the Aid flow (current US$) of Thailand in 2002 to that in 2003?
Provide a short and direct response. 0.55. What is the ratio of the Aid flow (current US$) in Colombia in 2002 to that in 2004?
Your answer should be compact. 0.71. What is the ratio of the Aid flow (current US$) in Malawi in 2002 to that in 2004?
Provide a succinct answer. 0.78. What is the ratio of the Aid flow (current US$) of Thailand in 2002 to that in 2004?
Your response must be concise. 0.4. What is the ratio of the Aid flow (current US$) in European Union in 2002 to that in 2006?
Your answer should be compact. 593.8. What is the ratio of the Aid flow (current US$) in Colombia in 2002 to that in 2006?
Make the answer very short. 1.48. What is the ratio of the Aid flow (current US$) of Malawi in 2002 to that in 2006?
Offer a terse response. 0.58. What is the ratio of the Aid flow (current US$) of Thailand in 2002 to that in 2006?
Provide a short and direct response. 0.42. What is the ratio of the Aid flow (current US$) of Colombia in 2002 to that in 2008?
Offer a terse response. 0.26. What is the ratio of the Aid flow (current US$) in Malawi in 2002 to that in 2008?
Offer a very short reply. 0.37. What is the ratio of the Aid flow (current US$) of Thailand in 2002 to that in 2008?
Your response must be concise. 0.51. What is the ratio of the Aid flow (current US$) of Colombia in 2003 to that in 2004?
Make the answer very short. 0.52. What is the ratio of the Aid flow (current US$) in Malawi in 2003 to that in 2004?
Ensure brevity in your answer.  0.22. What is the ratio of the Aid flow (current US$) of Thailand in 2003 to that in 2004?
Ensure brevity in your answer.  0.73. What is the ratio of the Aid flow (current US$) in European Union in 2003 to that in 2006?
Provide a succinct answer. 78.8. What is the ratio of the Aid flow (current US$) of Malawi in 2003 to that in 2006?
Provide a short and direct response. 0.17. What is the ratio of the Aid flow (current US$) in Thailand in 2003 to that in 2006?
Your answer should be compact. 0.77. What is the ratio of the Aid flow (current US$) in Colombia in 2003 to that in 2008?
Offer a very short reply. 0.19. What is the ratio of the Aid flow (current US$) in Malawi in 2003 to that in 2008?
Ensure brevity in your answer.  0.11. What is the ratio of the Aid flow (current US$) of Thailand in 2003 to that in 2008?
Your response must be concise. 0.93. What is the ratio of the Aid flow (current US$) of Colombia in 2004 to that in 2006?
Offer a very short reply. 2.08. What is the ratio of the Aid flow (current US$) of Malawi in 2004 to that in 2006?
Provide a short and direct response. 0.75. What is the ratio of the Aid flow (current US$) of Thailand in 2004 to that in 2006?
Provide a succinct answer. 1.06. What is the ratio of the Aid flow (current US$) of Colombia in 2004 to that in 2008?
Provide a short and direct response. 0.37. What is the ratio of the Aid flow (current US$) in Malawi in 2004 to that in 2008?
Give a very brief answer. 0.47. What is the ratio of the Aid flow (current US$) in Thailand in 2004 to that in 2008?
Provide a succinct answer. 1.27. What is the ratio of the Aid flow (current US$) in Colombia in 2006 to that in 2008?
Make the answer very short. 0.18. What is the ratio of the Aid flow (current US$) of Malawi in 2006 to that in 2008?
Give a very brief answer. 0.63. What is the ratio of the Aid flow (current US$) of Thailand in 2006 to that in 2008?
Your answer should be very brief. 1.2. What is the difference between the highest and the second highest Aid flow (current US$) of European Union?
Your answer should be very brief. 1.64e+07. What is the difference between the highest and the second highest Aid flow (current US$) in Thailand?
Offer a terse response. 1.30e+05. What is the difference between the highest and the lowest Aid flow (current US$) of European Union?
Offer a terse response. 2.97e+07. What is the difference between the highest and the lowest Aid flow (current US$) in Colombia?
Your answer should be very brief. 1.35e+06. What is the difference between the highest and the lowest Aid flow (current US$) of Thailand?
Your answer should be compact. 1.72e+06. 